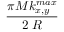Convert formula to latex. <formula><loc_0><loc_0><loc_500><loc_500>\frac { \pi M k _ { x , y } ^ { \max } } { 2 \, R }</formula> 